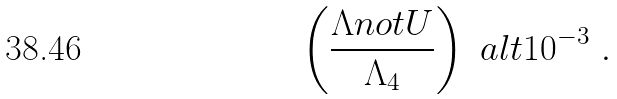<formula> <loc_0><loc_0><loc_500><loc_500>\left ( \frac { \Lambda n o t U } { \Lambda _ { 4 } } \right ) \ a l t 1 0 ^ { - 3 } \ .</formula> 